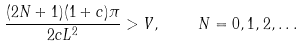Convert formula to latex. <formula><loc_0><loc_0><loc_500><loc_500>\frac { ( 2 N + 1 ) ( 1 + c ) \pi } { 2 c L ^ { 2 } } > V , \quad N = 0 , 1 , 2 , \dots</formula> 